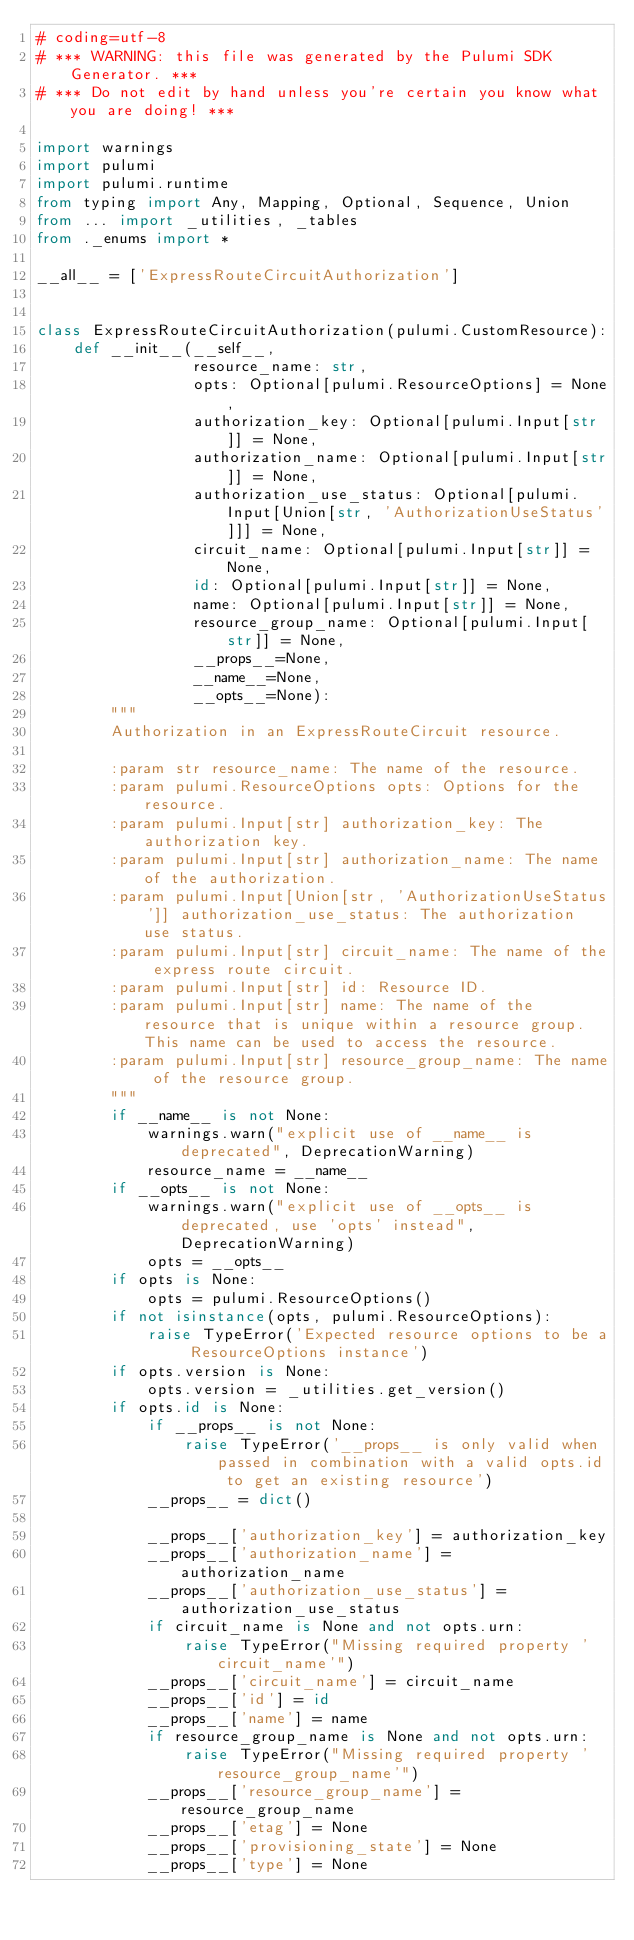<code> <loc_0><loc_0><loc_500><loc_500><_Python_># coding=utf-8
# *** WARNING: this file was generated by the Pulumi SDK Generator. ***
# *** Do not edit by hand unless you're certain you know what you are doing! ***

import warnings
import pulumi
import pulumi.runtime
from typing import Any, Mapping, Optional, Sequence, Union
from ... import _utilities, _tables
from ._enums import *

__all__ = ['ExpressRouteCircuitAuthorization']


class ExpressRouteCircuitAuthorization(pulumi.CustomResource):
    def __init__(__self__,
                 resource_name: str,
                 opts: Optional[pulumi.ResourceOptions] = None,
                 authorization_key: Optional[pulumi.Input[str]] = None,
                 authorization_name: Optional[pulumi.Input[str]] = None,
                 authorization_use_status: Optional[pulumi.Input[Union[str, 'AuthorizationUseStatus']]] = None,
                 circuit_name: Optional[pulumi.Input[str]] = None,
                 id: Optional[pulumi.Input[str]] = None,
                 name: Optional[pulumi.Input[str]] = None,
                 resource_group_name: Optional[pulumi.Input[str]] = None,
                 __props__=None,
                 __name__=None,
                 __opts__=None):
        """
        Authorization in an ExpressRouteCircuit resource.

        :param str resource_name: The name of the resource.
        :param pulumi.ResourceOptions opts: Options for the resource.
        :param pulumi.Input[str] authorization_key: The authorization key.
        :param pulumi.Input[str] authorization_name: The name of the authorization.
        :param pulumi.Input[Union[str, 'AuthorizationUseStatus']] authorization_use_status: The authorization use status.
        :param pulumi.Input[str] circuit_name: The name of the express route circuit.
        :param pulumi.Input[str] id: Resource ID.
        :param pulumi.Input[str] name: The name of the resource that is unique within a resource group. This name can be used to access the resource.
        :param pulumi.Input[str] resource_group_name: The name of the resource group.
        """
        if __name__ is not None:
            warnings.warn("explicit use of __name__ is deprecated", DeprecationWarning)
            resource_name = __name__
        if __opts__ is not None:
            warnings.warn("explicit use of __opts__ is deprecated, use 'opts' instead", DeprecationWarning)
            opts = __opts__
        if opts is None:
            opts = pulumi.ResourceOptions()
        if not isinstance(opts, pulumi.ResourceOptions):
            raise TypeError('Expected resource options to be a ResourceOptions instance')
        if opts.version is None:
            opts.version = _utilities.get_version()
        if opts.id is None:
            if __props__ is not None:
                raise TypeError('__props__ is only valid when passed in combination with a valid opts.id to get an existing resource')
            __props__ = dict()

            __props__['authorization_key'] = authorization_key
            __props__['authorization_name'] = authorization_name
            __props__['authorization_use_status'] = authorization_use_status
            if circuit_name is None and not opts.urn:
                raise TypeError("Missing required property 'circuit_name'")
            __props__['circuit_name'] = circuit_name
            __props__['id'] = id
            __props__['name'] = name
            if resource_group_name is None and not opts.urn:
                raise TypeError("Missing required property 'resource_group_name'")
            __props__['resource_group_name'] = resource_group_name
            __props__['etag'] = None
            __props__['provisioning_state'] = None
            __props__['type'] = None</code> 